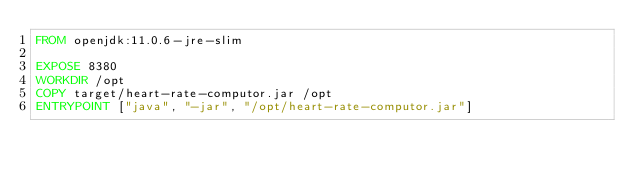<code> <loc_0><loc_0><loc_500><loc_500><_Dockerfile_>FROM openjdk:11.0.6-jre-slim

EXPOSE 8380
WORKDIR /opt
COPY target/heart-rate-computor.jar /opt
ENTRYPOINT ["java", "-jar", "/opt/heart-rate-computor.jar"]
</code> 